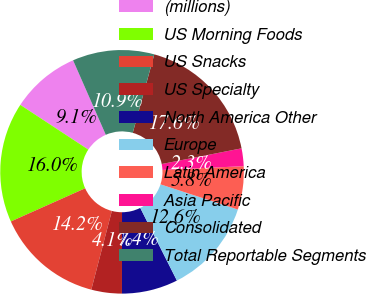<chart> <loc_0><loc_0><loc_500><loc_500><pie_chart><fcel>(millions)<fcel>US Morning Foods<fcel>US Snacks<fcel>US Specialty<fcel>North America Other<fcel>Europe<fcel>Latin America<fcel>Asia Pacific<fcel>Consolidated<fcel>Total Reportable Segments<nl><fcel>9.15%<fcel>15.95%<fcel>14.25%<fcel>4.05%<fcel>7.45%<fcel>12.55%<fcel>5.75%<fcel>2.35%<fcel>17.65%<fcel>10.85%<nl></chart> 